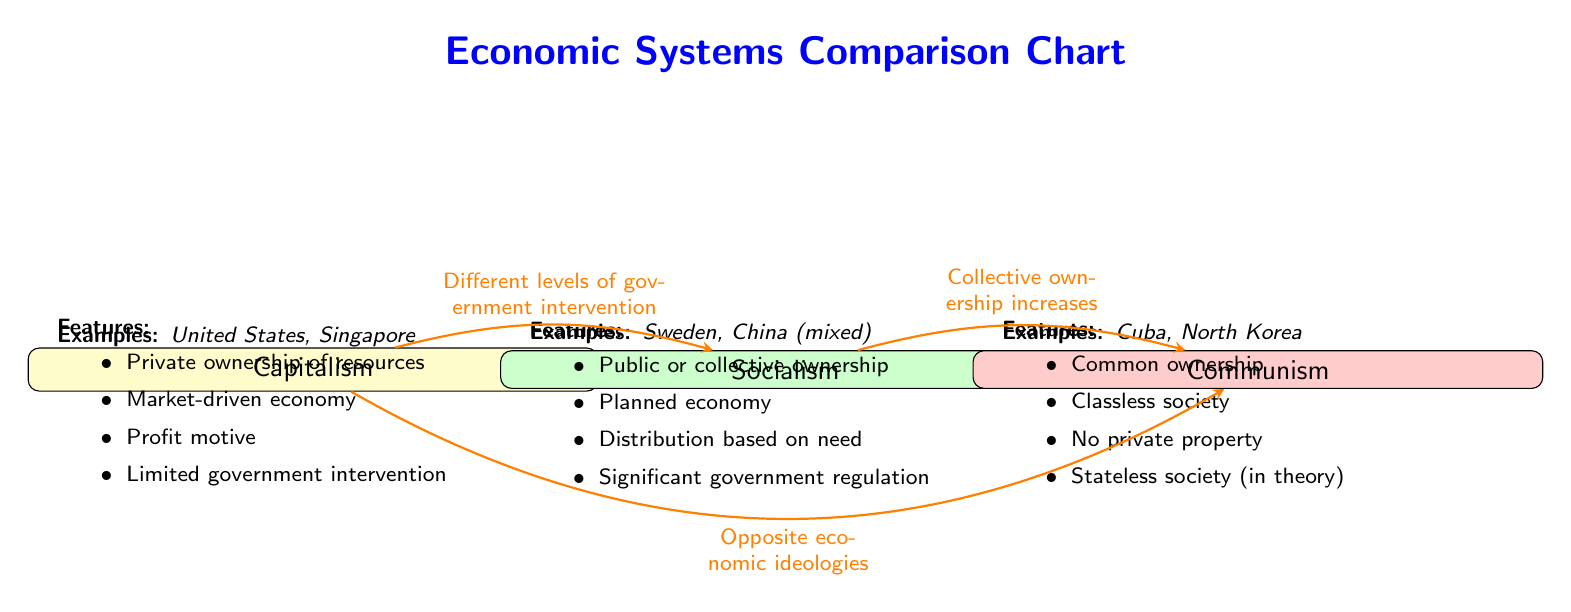What are the key features of capitalism? The diagram lists the key features of capitalism in a bullet-point format under the capitalism node. It includes private ownership of resources, a market-driven economy, the profit motive, and limited government intervention.
Answer: Private ownership of resources, market-driven economy, profit motive, limited government intervention How many economic systems are compared in this diagram? The diagram visually represents three distinct economic systems: capitalism, socialism, and communism. The count is observed by identifying the number of system nodes present.
Answer: 3 What color represents socialism in the diagram? The socialism system in the diagram is filled with a green color. This can be directly seen in the node that denotes socialism.
Answer: Green Which economic system is described as having no private property? The feature that describes having no private property is listed under the communism node, which specifically includes "No private property" as one of its key features.
Answer: Communism What is the relationship between socialism and communism as shown in the diagram? The diagram indicates that socialism leads to communism with an edge labeled "Collective ownership increases," which points from socialism to communism. This implies a progression or deepening of economic structure.
Answer: Collective ownership increases List an example of capitalism. The diagram specifies that examples of capitalism include the United States and Singapore. This information is presented directly under the capitalism node.
Answer: United States, Singapore What type of economy does socialism have according to the diagram? Under the socialism node, it states that socialism has a planned economy as one of its features, distinguishing it from the market-driven approach of capitalism.
Answer: Planned economy Which economic system is noted for significant government regulation? The feature of significant government regulation is associated with socialism in the diagram, highlighting its structured approach to economic management.
Answer: Socialism 